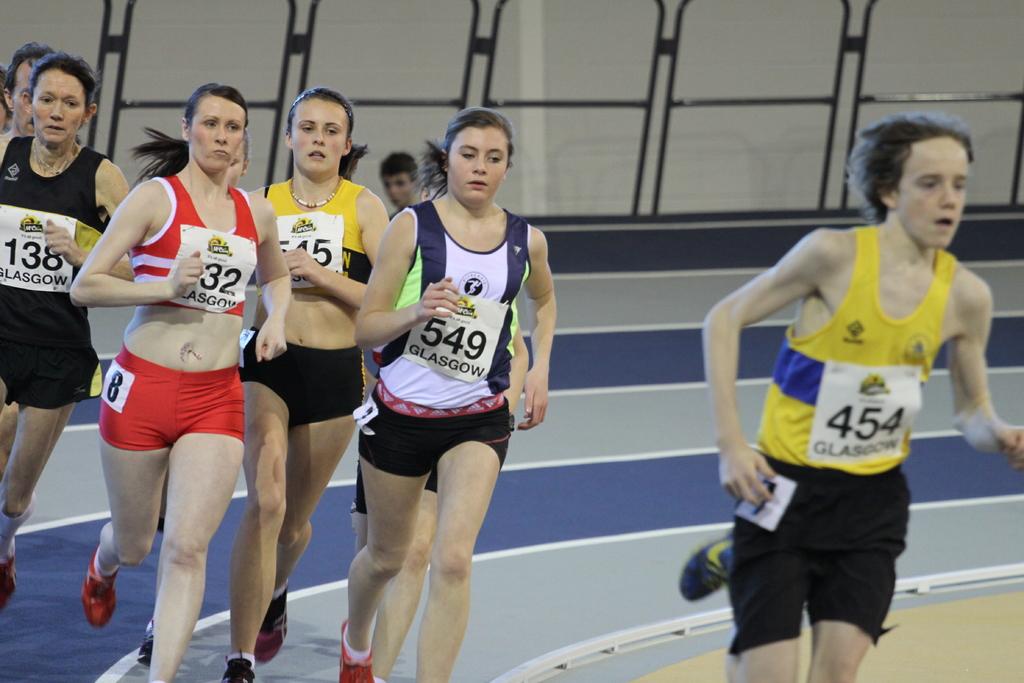What number is the woman in red?
Offer a very short reply. 32. 